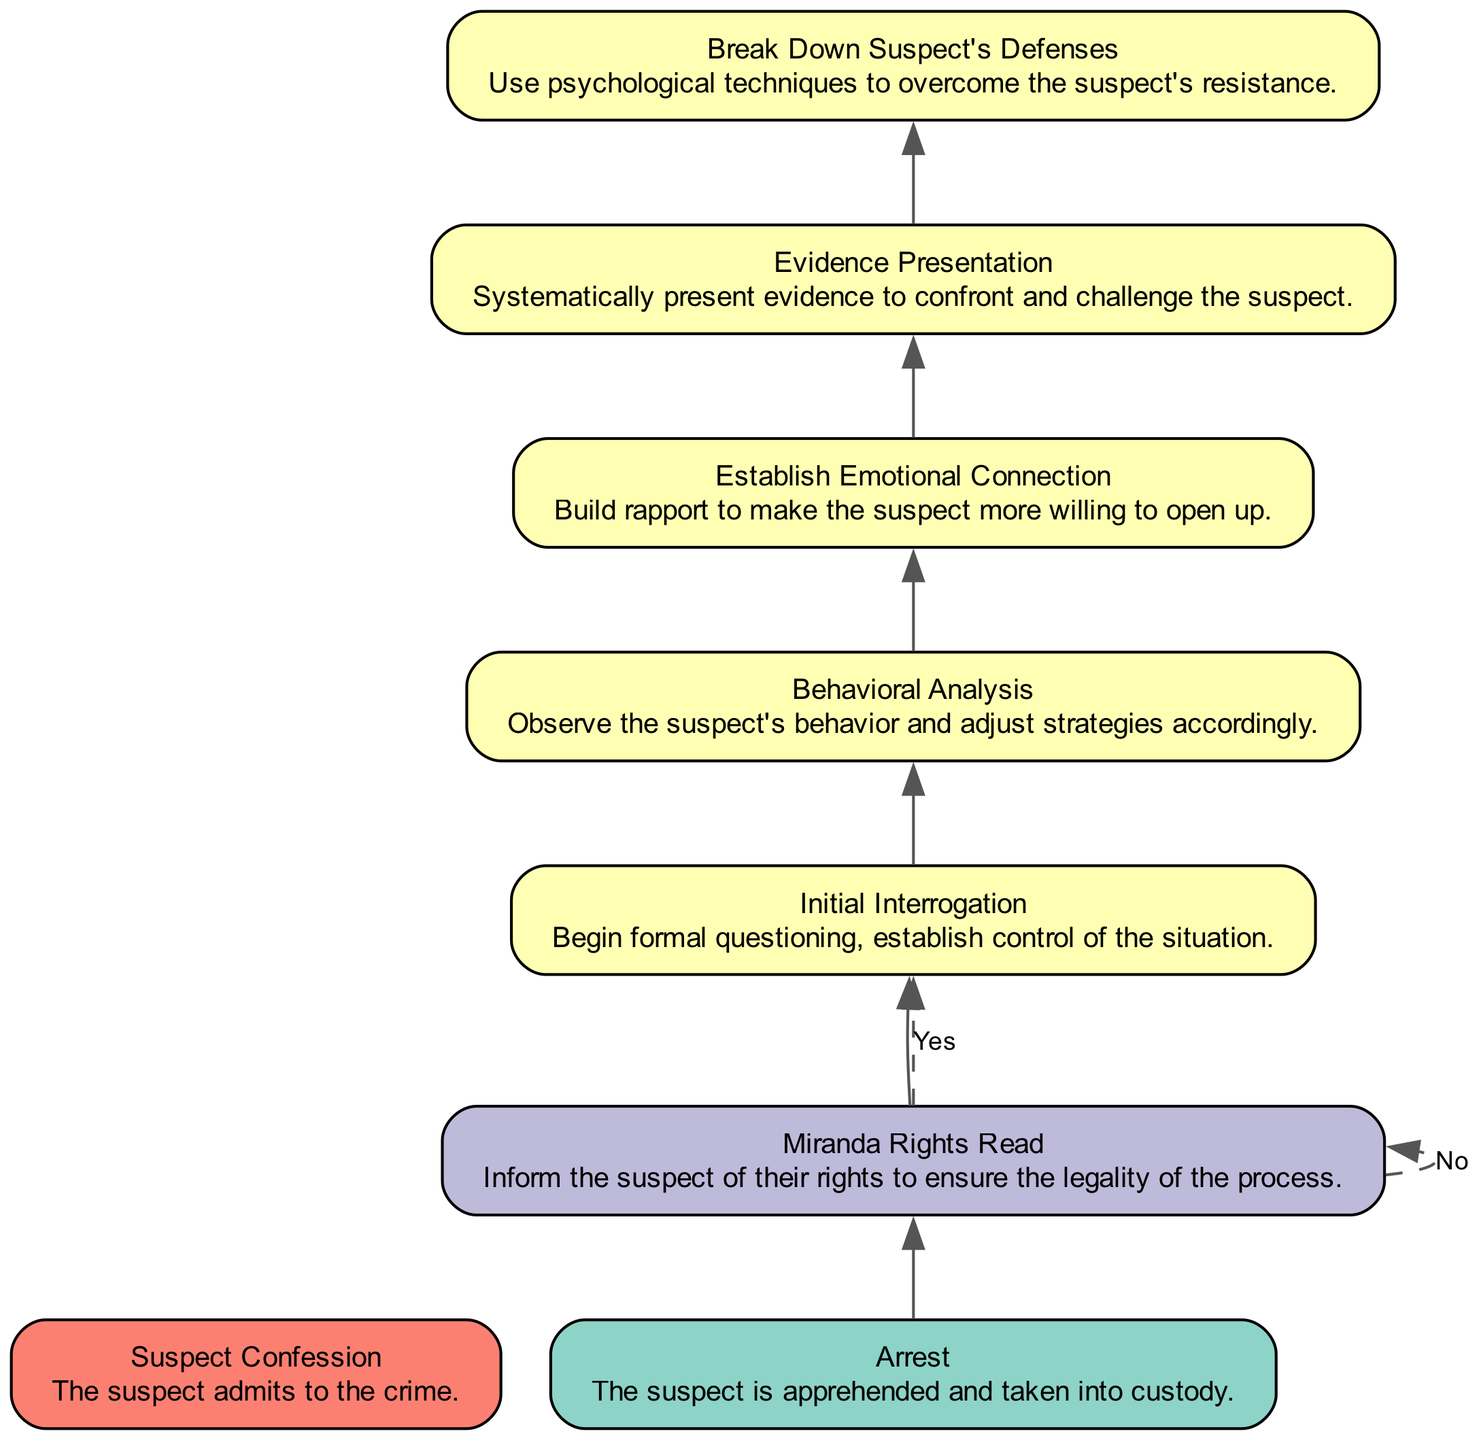What is the first step in the interrogation process? The first step in the interrogation process is the "Arrest," which indicates the suspect is apprehended and taken into custody. This is represented as the starting point in the diagram.
Answer: Arrest What type of node is "Evidence Presentation"? "Evidence Presentation" is classified as a "process" node in the diagram, which means it represents an activity or action taken during the interrogation process.
Answer: process Which step follows "Initial Interrogation"? The step that follows "Initial Interrogation" is "Behavioral Analysis," where the investigator observes the suspect’s behavior to adjust strategies accordingly.
Answer: Behavioral Analysis What type of node is at the end of the process? The node at the end of the process is a type "end" node, specifically "Suspect Confession," which signifies the completion of the interrogation when the suspect admits to the crime.
Answer: end How many decision nodes are present in the diagram? There is one decision node in the diagram, which is the "Miranda Rights Read." This node requires a yes or no answer regarding the informing of the suspect's rights.
Answer: 1 Which step occurs before "Break Down Suspect's Defenses"? "Evidence Presentation" occurs before "Break Down Suspect's Defenses." This relationship indicates that evidence is presented systematically to confront the suspect, leading to breaking down defenses.
Answer: Evidence Presentation What process involves building rapport with the suspect? The process that involves building rapport with the suspect is "Establish Emotional Connection," which aims to make the suspect more willing to open up during the interrogation.
Answer: Establish Emotional Connection Which two nodes lead to the "Suspect Confession" node? The nodes that lead to "Suspect Confession" are "Break Down Suspect's Defenses" and "Evidence Presentation," indicating that both processes are critical for eliciting a confession.
Answer: Break Down Suspect's Defenses, Evidence Presentation What is the relationship between "Miranda Rights Read" and "Initial Interrogation"? "Miranda Rights Read" is a decision node that must be resolved (yes or no) before proceeding to "Initial Interrogation," making it a prerequisite for this step in the process.
Answer: prerequisite 